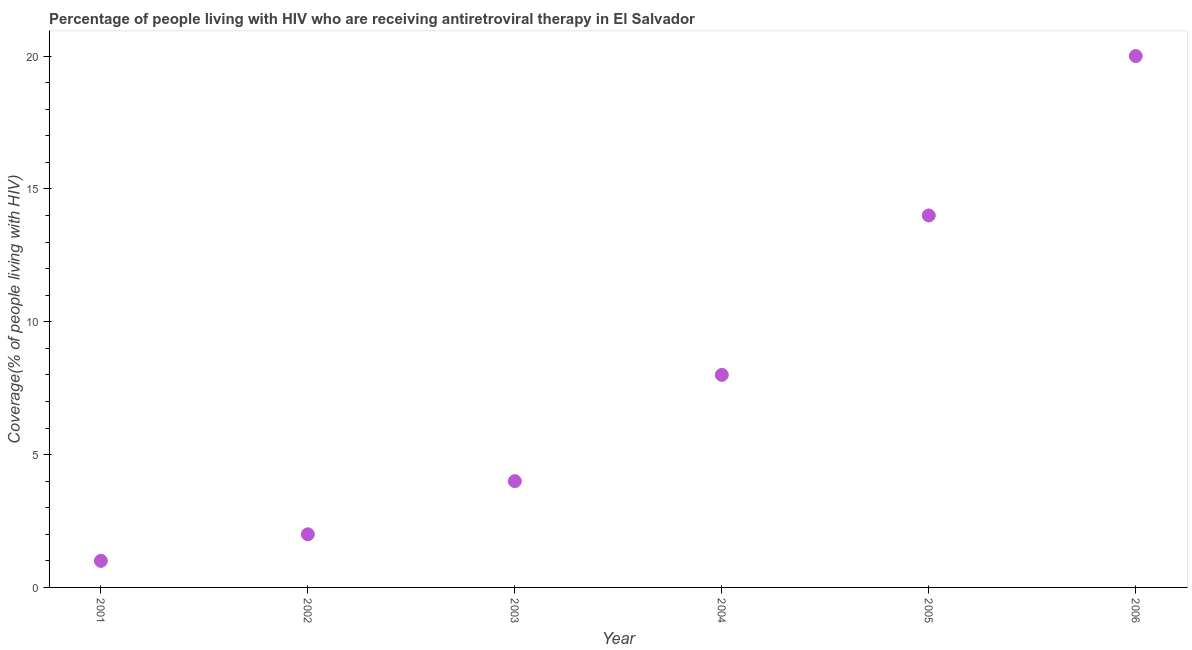What is the antiretroviral therapy coverage in 2003?
Provide a short and direct response. 4. Across all years, what is the maximum antiretroviral therapy coverage?
Provide a succinct answer. 20. Across all years, what is the minimum antiretroviral therapy coverage?
Offer a terse response. 1. In which year was the antiretroviral therapy coverage minimum?
Keep it short and to the point. 2001. What is the sum of the antiretroviral therapy coverage?
Your answer should be compact. 49. What is the difference between the antiretroviral therapy coverage in 2001 and 2003?
Ensure brevity in your answer.  -3. What is the average antiretroviral therapy coverage per year?
Ensure brevity in your answer.  8.17. What is the median antiretroviral therapy coverage?
Offer a terse response. 6. In how many years, is the antiretroviral therapy coverage greater than 14 %?
Provide a short and direct response. 1. Do a majority of the years between 2001 and 2003 (inclusive) have antiretroviral therapy coverage greater than 15 %?
Provide a succinct answer. No. Is the difference between the antiretroviral therapy coverage in 2003 and 2004 greater than the difference between any two years?
Make the answer very short. No. Is the sum of the antiretroviral therapy coverage in 2002 and 2006 greater than the maximum antiretroviral therapy coverage across all years?
Make the answer very short. Yes. What is the difference between the highest and the lowest antiretroviral therapy coverage?
Give a very brief answer. 19. In how many years, is the antiretroviral therapy coverage greater than the average antiretroviral therapy coverage taken over all years?
Provide a succinct answer. 2. Does the antiretroviral therapy coverage monotonically increase over the years?
Your answer should be compact. Yes. How many years are there in the graph?
Your answer should be very brief. 6. What is the difference between two consecutive major ticks on the Y-axis?
Your answer should be compact. 5. Does the graph contain grids?
Give a very brief answer. No. What is the title of the graph?
Provide a short and direct response. Percentage of people living with HIV who are receiving antiretroviral therapy in El Salvador. What is the label or title of the Y-axis?
Your response must be concise. Coverage(% of people living with HIV). What is the Coverage(% of people living with HIV) in 2001?
Offer a terse response. 1. What is the difference between the Coverage(% of people living with HIV) in 2001 and 2002?
Your response must be concise. -1. What is the difference between the Coverage(% of people living with HIV) in 2001 and 2005?
Provide a short and direct response. -13. What is the difference between the Coverage(% of people living with HIV) in 2001 and 2006?
Make the answer very short. -19. What is the difference between the Coverage(% of people living with HIV) in 2002 and 2003?
Offer a terse response. -2. What is the difference between the Coverage(% of people living with HIV) in 2002 and 2005?
Your answer should be very brief. -12. What is the difference between the Coverage(% of people living with HIV) in 2002 and 2006?
Offer a very short reply. -18. What is the difference between the Coverage(% of people living with HIV) in 2003 and 2004?
Make the answer very short. -4. What is the difference between the Coverage(% of people living with HIV) in 2004 and 2005?
Your answer should be very brief. -6. What is the ratio of the Coverage(% of people living with HIV) in 2001 to that in 2002?
Offer a terse response. 0.5. What is the ratio of the Coverage(% of people living with HIV) in 2001 to that in 2005?
Give a very brief answer. 0.07. What is the ratio of the Coverage(% of people living with HIV) in 2002 to that in 2003?
Provide a short and direct response. 0.5. What is the ratio of the Coverage(% of people living with HIV) in 2002 to that in 2005?
Ensure brevity in your answer.  0.14. What is the ratio of the Coverage(% of people living with HIV) in 2002 to that in 2006?
Ensure brevity in your answer.  0.1. What is the ratio of the Coverage(% of people living with HIV) in 2003 to that in 2004?
Your answer should be very brief. 0.5. What is the ratio of the Coverage(% of people living with HIV) in 2003 to that in 2005?
Your answer should be very brief. 0.29. What is the ratio of the Coverage(% of people living with HIV) in 2004 to that in 2005?
Give a very brief answer. 0.57. 